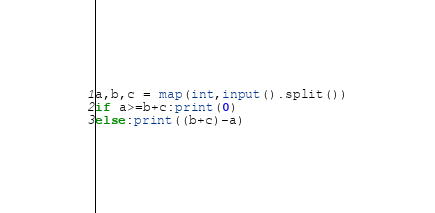<code> <loc_0><loc_0><loc_500><loc_500><_Python_>a,b,c = map(int,input().split())
if a>=b+c:print(0)
else:print((b+c)-a)
</code> 